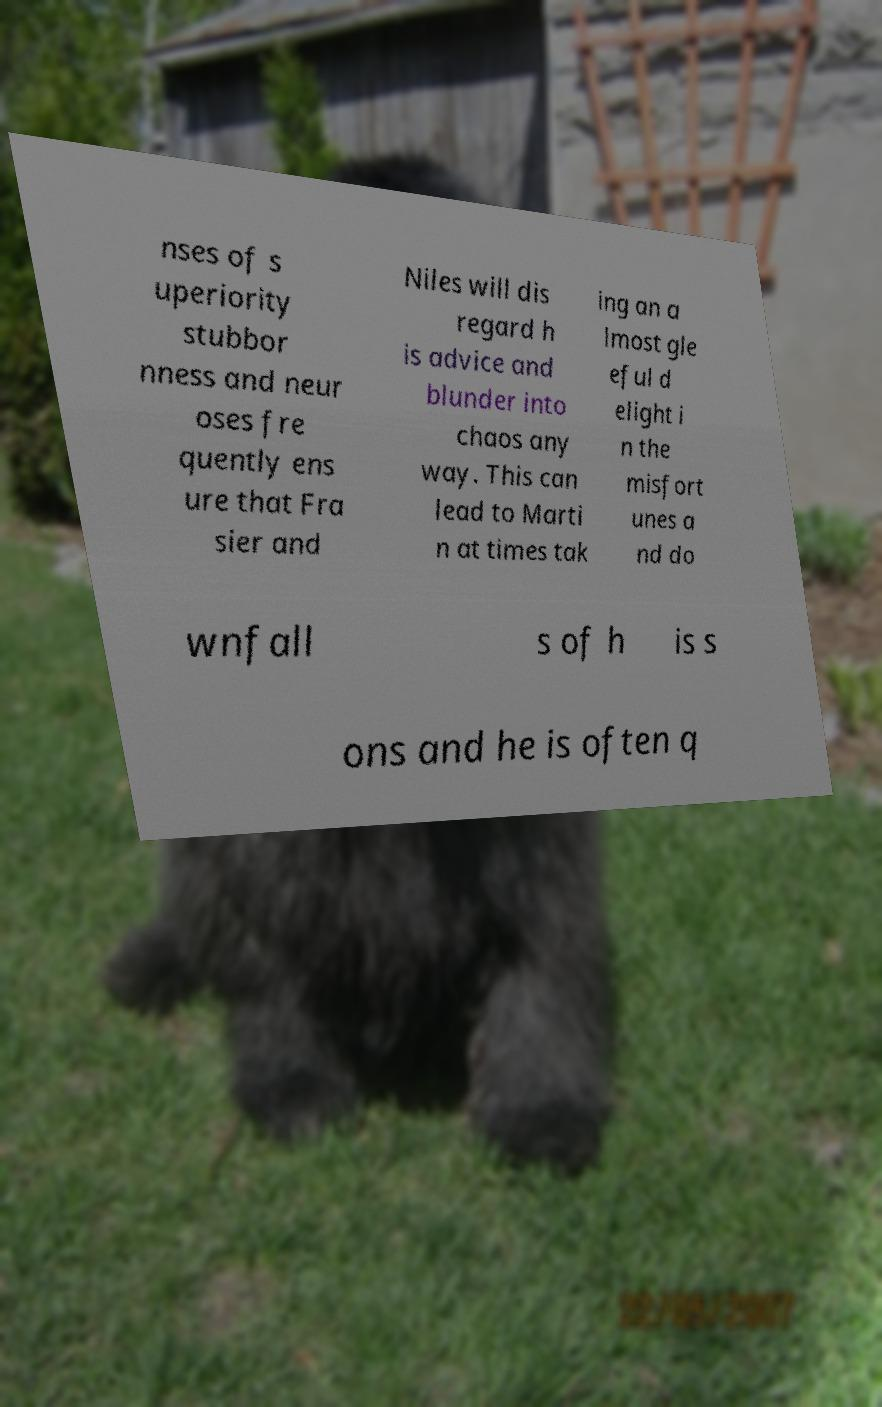Please identify and transcribe the text found in this image. nses of s uperiority stubbor nness and neur oses fre quently ens ure that Fra sier and Niles will dis regard h is advice and blunder into chaos any way. This can lead to Marti n at times tak ing an a lmost gle eful d elight i n the misfort unes a nd do wnfall s of h is s ons and he is often q 